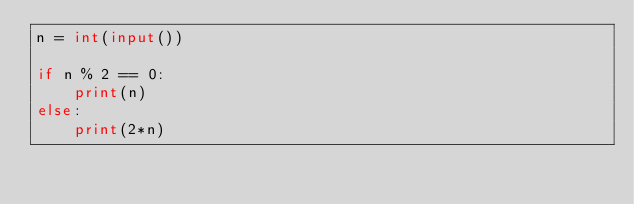<code> <loc_0><loc_0><loc_500><loc_500><_Python_>n = int(input())

if n % 2 == 0:
    print(n)
else:
    print(2*n)</code> 